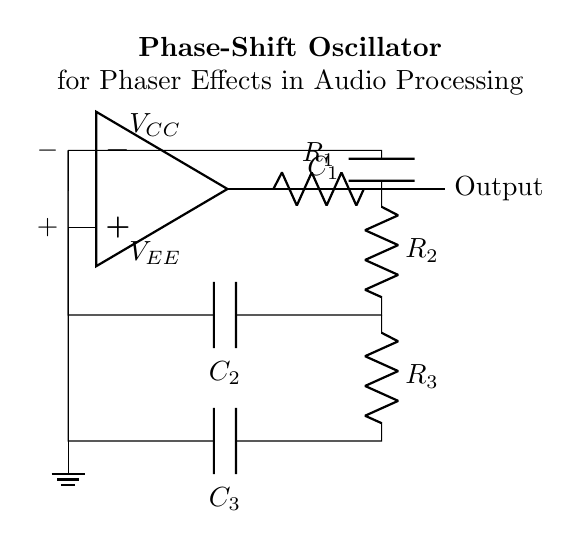What type of oscillator is represented in the circuit? The circuit is a phase-shift oscillator, characterized by the feedback network that creates the necessary phase shift for oscillation.
Answer: phase-shift oscillator What are the passive components used in this oscillator? The circuit diagram features resistors and capacitors, which are essential for controlling the oscillation frequency and behavior.
Answer: resistors and capacitors How many resistors are in the feedback network? There are three resistors present in the feedback network, labeled R1, R2, and R3, which assist in setting the gain and phase shift.
Answer: three What do the capacitors in the circuit primarily affect? The capacitors influence the timing and frequency of the oscillations, as they work in tandem with the resistors to determine the phase shift required for sustained oscillation.
Answer: frequency of oscillations What is the purpose of the operational amplifier in this circuit? The operational amplifier acts as a voltage amplifier that creates the necessary gain for the oscillator to maintain oscillations while also providing the required phase shift.
Answer: voltage amplifier What should the total phase shift be for sustained oscillation in this circuit? For sustained oscillation, the total phase shift around the loop must equal 360 degrees (or 0 degrees), which is crucial for the feedback to reinforce the oscillation.
Answer: 360 degrees What is the role of ground in this oscillator configuration? The ground serves as a reference point for the circuit, ensuring stability and proper functioning by providing a common return path for current.
Answer: reference point 